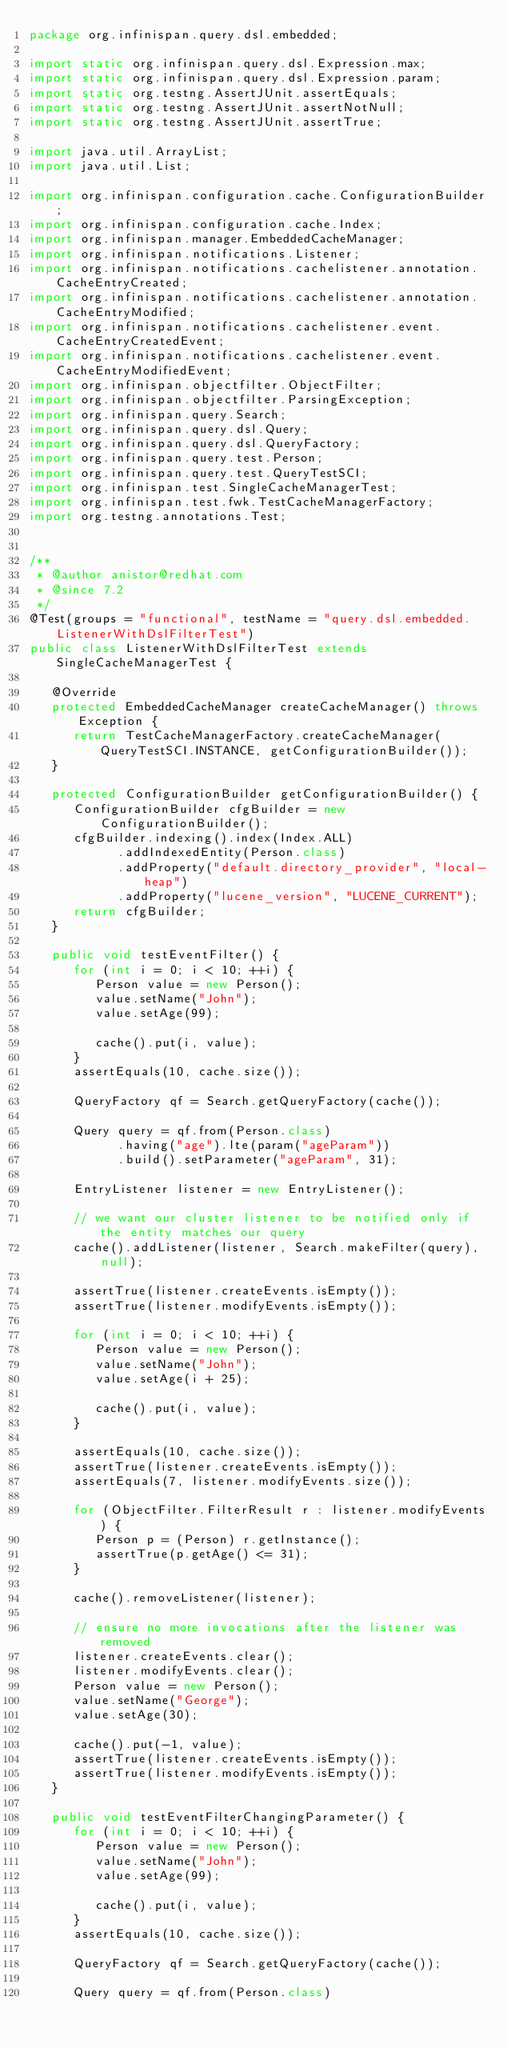Convert code to text. <code><loc_0><loc_0><loc_500><loc_500><_Java_>package org.infinispan.query.dsl.embedded;

import static org.infinispan.query.dsl.Expression.max;
import static org.infinispan.query.dsl.Expression.param;
import static org.testng.AssertJUnit.assertEquals;
import static org.testng.AssertJUnit.assertNotNull;
import static org.testng.AssertJUnit.assertTrue;

import java.util.ArrayList;
import java.util.List;

import org.infinispan.configuration.cache.ConfigurationBuilder;
import org.infinispan.configuration.cache.Index;
import org.infinispan.manager.EmbeddedCacheManager;
import org.infinispan.notifications.Listener;
import org.infinispan.notifications.cachelistener.annotation.CacheEntryCreated;
import org.infinispan.notifications.cachelistener.annotation.CacheEntryModified;
import org.infinispan.notifications.cachelistener.event.CacheEntryCreatedEvent;
import org.infinispan.notifications.cachelistener.event.CacheEntryModifiedEvent;
import org.infinispan.objectfilter.ObjectFilter;
import org.infinispan.objectfilter.ParsingException;
import org.infinispan.query.Search;
import org.infinispan.query.dsl.Query;
import org.infinispan.query.dsl.QueryFactory;
import org.infinispan.query.test.Person;
import org.infinispan.query.test.QueryTestSCI;
import org.infinispan.test.SingleCacheManagerTest;
import org.infinispan.test.fwk.TestCacheManagerFactory;
import org.testng.annotations.Test;


/**
 * @author anistor@redhat.com
 * @since 7.2
 */
@Test(groups = "functional", testName = "query.dsl.embedded.ListenerWithDslFilterTest")
public class ListenerWithDslFilterTest extends SingleCacheManagerTest {

   @Override
   protected EmbeddedCacheManager createCacheManager() throws Exception {
      return TestCacheManagerFactory.createCacheManager(QueryTestSCI.INSTANCE, getConfigurationBuilder());
   }

   protected ConfigurationBuilder getConfigurationBuilder() {
      ConfigurationBuilder cfgBuilder = new ConfigurationBuilder();
      cfgBuilder.indexing().index(Index.ALL)
            .addIndexedEntity(Person.class)
            .addProperty("default.directory_provider", "local-heap")
            .addProperty("lucene_version", "LUCENE_CURRENT");
      return cfgBuilder;
   }

   public void testEventFilter() {
      for (int i = 0; i < 10; ++i) {
         Person value = new Person();
         value.setName("John");
         value.setAge(99);

         cache().put(i, value);
      }
      assertEquals(10, cache.size());

      QueryFactory qf = Search.getQueryFactory(cache());

      Query query = qf.from(Person.class)
            .having("age").lte(param("ageParam"))
            .build().setParameter("ageParam", 31);

      EntryListener listener = new EntryListener();

      // we want our cluster listener to be notified only if the entity matches our query
      cache().addListener(listener, Search.makeFilter(query), null);

      assertTrue(listener.createEvents.isEmpty());
      assertTrue(listener.modifyEvents.isEmpty());

      for (int i = 0; i < 10; ++i) {
         Person value = new Person();
         value.setName("John");
         value.setAge(i + 25);

         cache().put(i, value);
      }

      assertEquals(10, cache.size());
      assertTrue(listener.createEvents.isEmpty());
      assertEquals(7, listener.modifyEvents.size());

      for (ObjectFilter.FilterResult r : listener.modifyEvents) {
         Person p = (Person) r.getInstance();
         assertTrue(p.getAge() <= 31);
      }

      cache().removeListener(listener);

      // ensure no more invocations after the listener was removed
      listener.createEvents.clear();
      listener.modifyEvents.clear();
      Person value = new Person();
      value.setName("George");
      value.setAge(30);

      cache().put(-1, value);
      assertTrue(listener.createEvents.isEmpty());
      assertTrue(listener.modifyEvents.isEmpty());
   }

   public void testEventFilterChangingParameter() {
      for (int i = 0; i < 10; ++i) {
         Person value = new Person();
         value.setName("John");
         value.setAge(99);

         cache().put(i, value);
      }
      assertEquals(10, cache.size());

      QueryFactory qf = Search.getQueryFactory(cache());

      Query query = qf.from(Person.class)</code> 